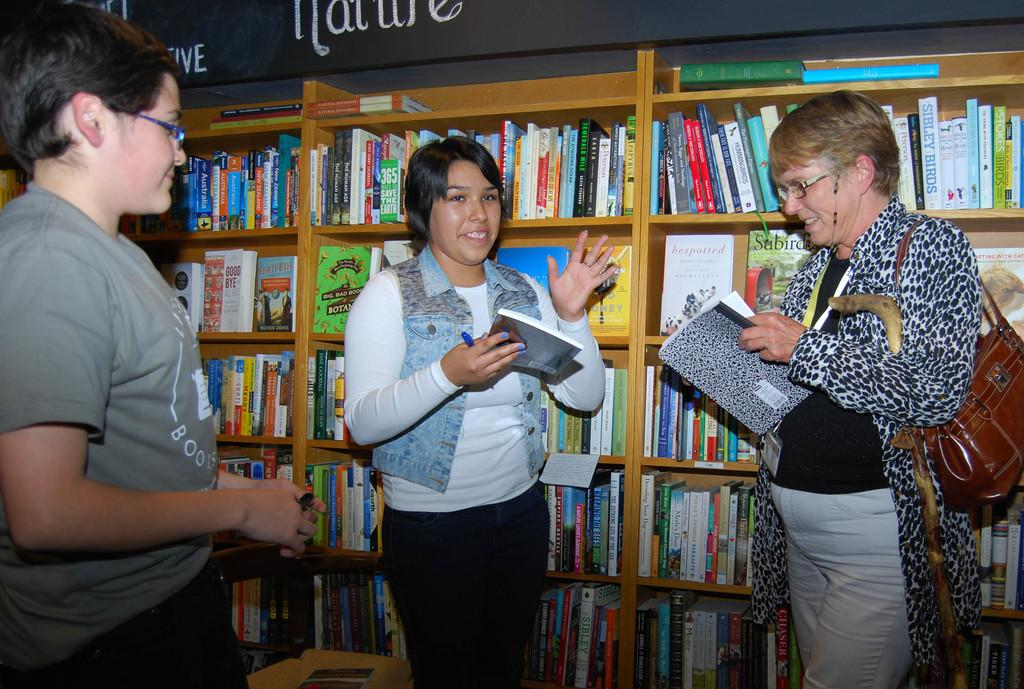<image>
Relay a brief, clear account of the picture shown. Three women are talking in a library in the Nature section. 